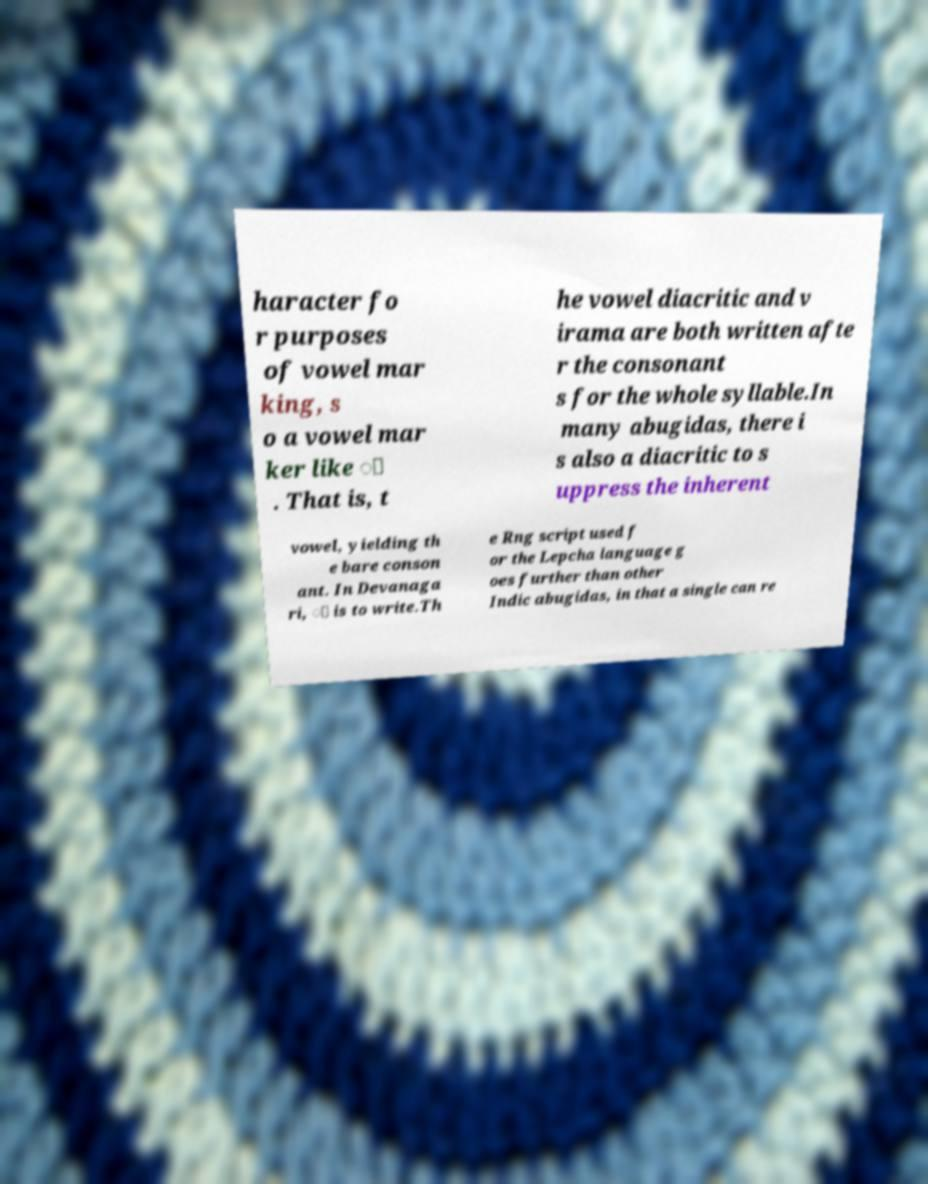Can you read and provide the text displayed in the image?This photo seems to have some interesting text. Can you extract and type it out for me? haracter fo r purposes of vowel mar king, s o a vowel mar ker like ि . That is, t he vowel diacritic and v irama are both written afte r the consonant s for the whole syllable.In many abugidas, there i s also a diacritic to s uppress the inherent vowel, yielding th e bare conson ant. In Devanaga ri, ् is to write.Th e Rng script used f or the Lepcha language g oes further than other Indic abugidas, in that a single can re 